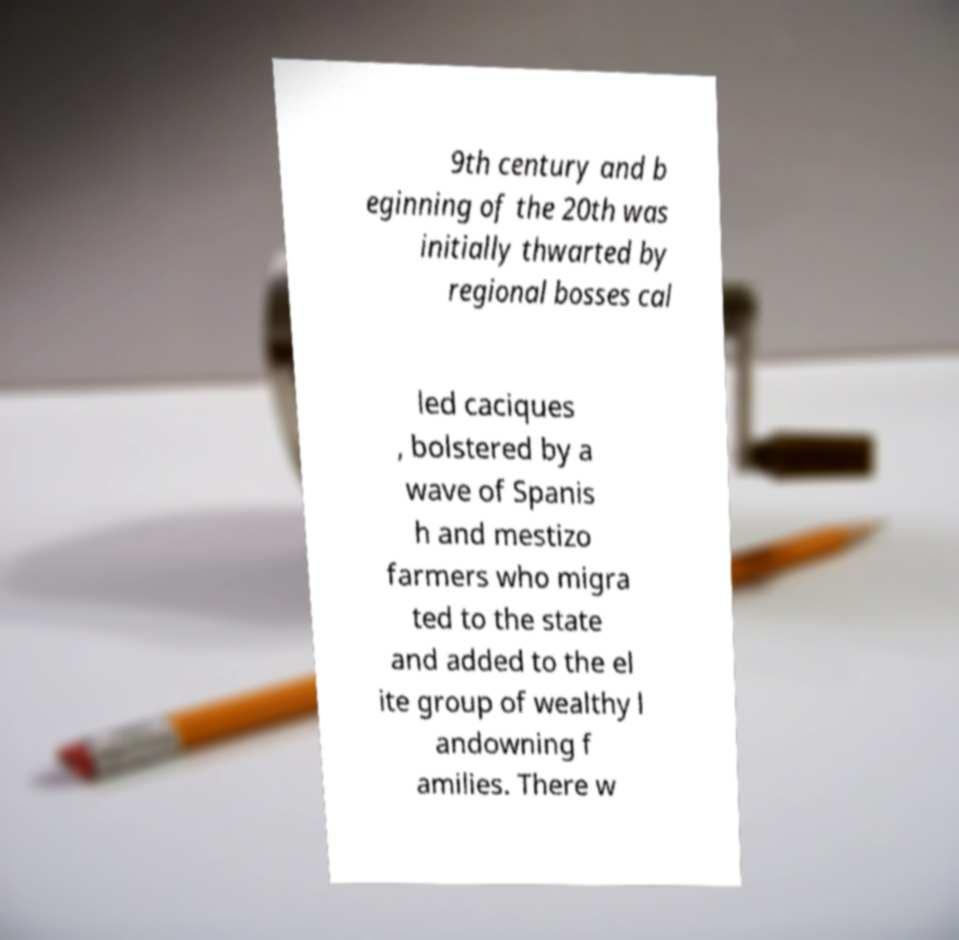For documentation purposes, I need the text within this image transcribed. Could you provide that? 9th century and b eginning of the 20th was initially thwarted by regional bosses cal led caciques , bolstered by a wave of Spanis h and mestizo farmers who migra ted to the state and added to the el ite group of wealthy l andowning f amilies. There w 